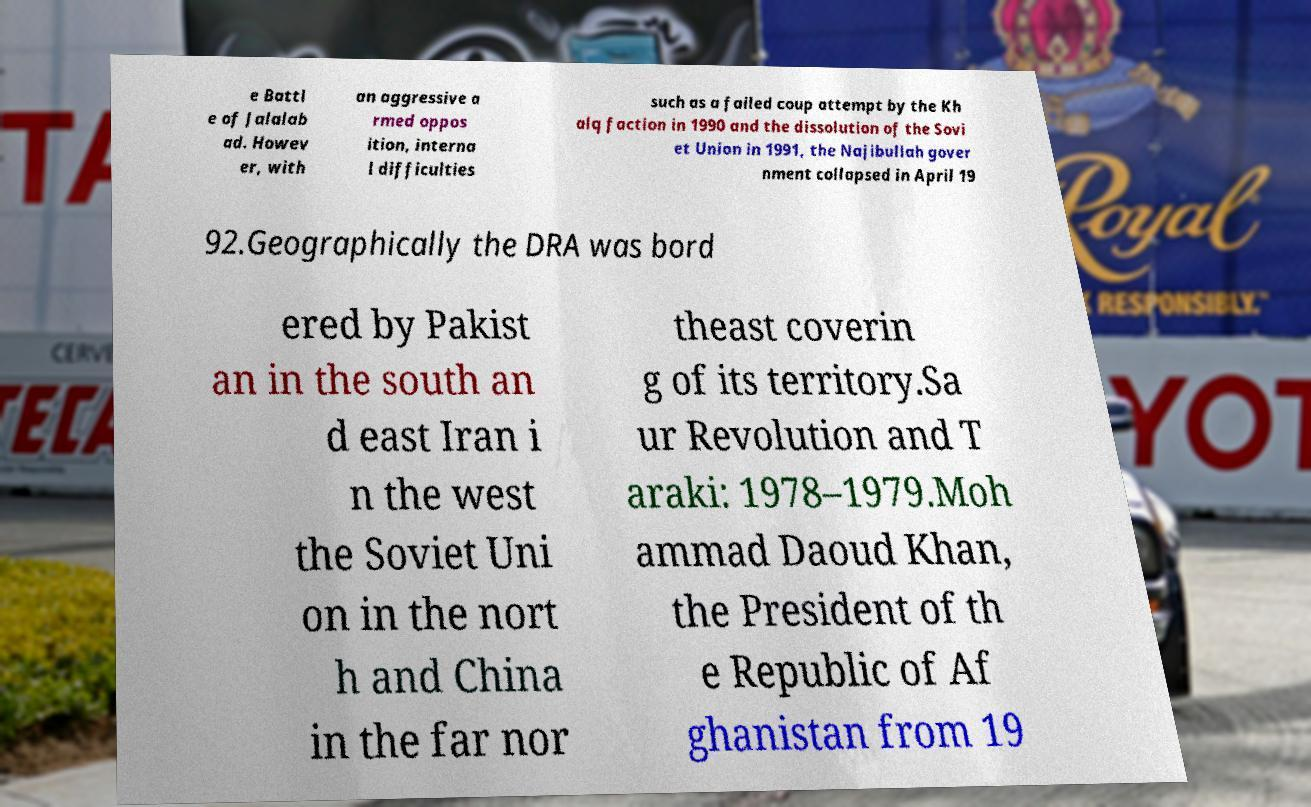Please identify and transcribe the text found in this image. e Battl e of Jalalab ad. Howev er, with an aggressive a rmed oppos ition, interna l difficulties such as a failed coup attempt by the Kh alq faction in 1990 and the dissolution of the Sovi et Union in 1991, the Najibullah gover nment collapsed in April 19 92.Geographically the DRA was bord ered by Pakist an in the south an d east Iran i n the west the Soviet Uni on in the nort h and China in the far nor theast coverin g of its territory.Sa ur Revolution and T araki: 1978–1979.Moh ammad Daoud Khan, the President of th e Republic of Af ghanistan from 19 